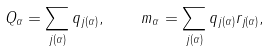Convert formula to latex. <formula><loc_0><loc_0><loc_500><loc_500>Q _ { \alpha } = \sum _ { j ( \alpha ) } q _ { j ( \alpha ) } , \quad m _ { \alpha } = \sum _ { j ( \alpha ) } q _ { j ( \alpha ) } r _ { j ( \alpha ) } ,</formula> 